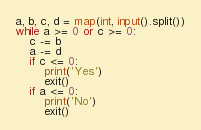<code> <loc_0><loc_0><loc_500><loc_500><_Python_>a, b, c, d = map(int, input().split())
while a >= 0 or c >= 0:
	c -= b
	a -= d
	if c <= 0:
		print('Yes')
		exit()
	if a <= 0:
		print('No')
		exit()</code> 